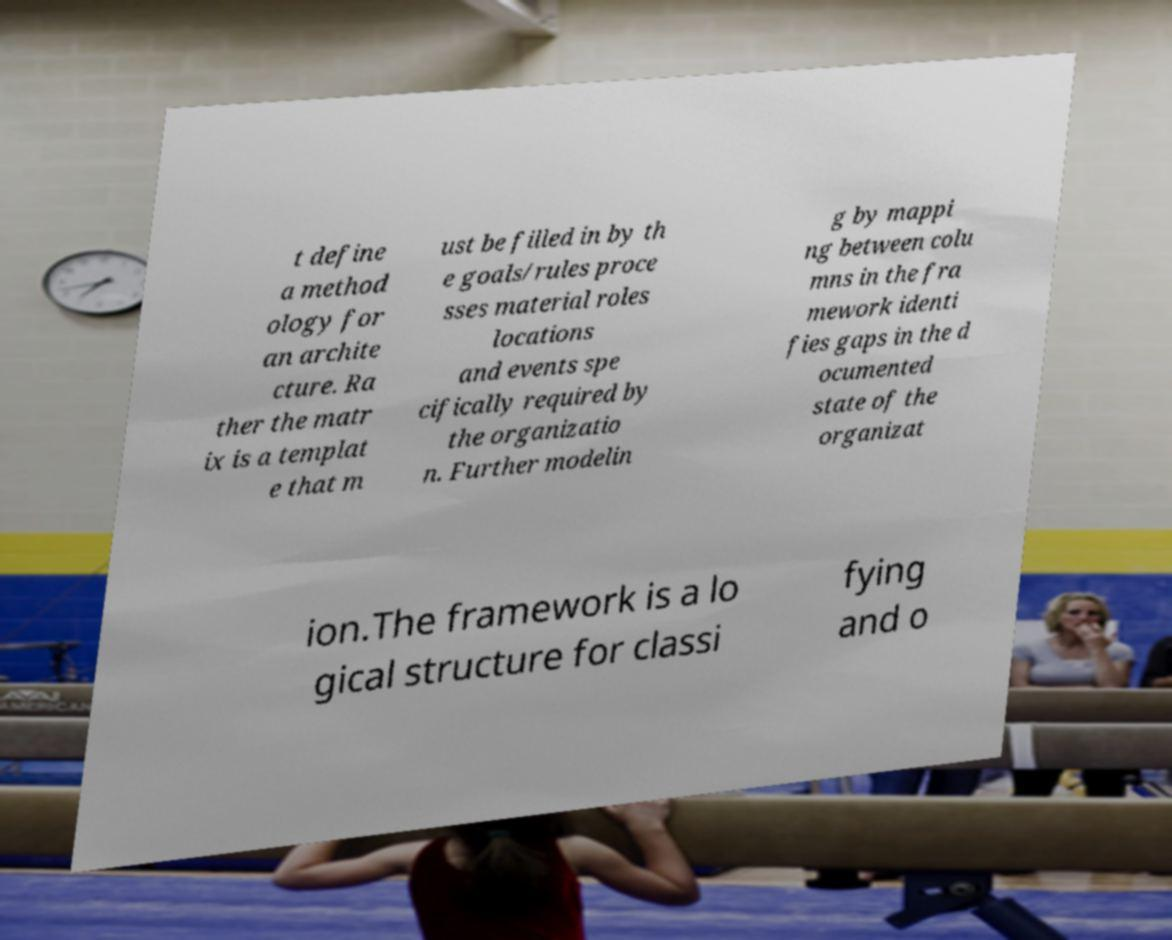Could you assist in decoding the text presented in this image and type it out clearly? t define a method ology for an archite cture. Ra ther the matr ix is a templat e that m ust be filled in by th e goals/rules proce sses material roles locations and events spe cifically required by the organizatio n. Further modelin g by mappi ng between colu mns in the fra mework identi fies gaps in the d ocumented state of the organizat ion.The framework is a lo gical structure for classi fying and o 